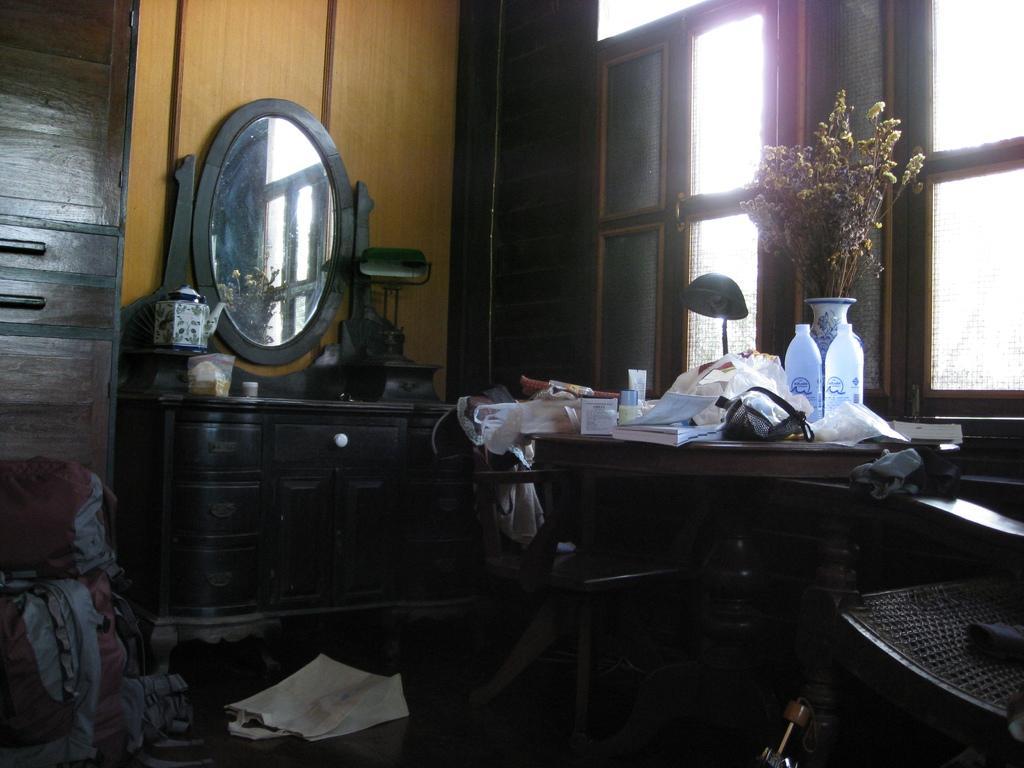How would you summarize this image in a sentence or two? In this picture we observe many wooden furniture. A glass mirror is placed on top of a brown wooden stand and a pair of bottles and a flower vase kept on another table. This picture is clicked inside the room. In the background we observe designed windows. 